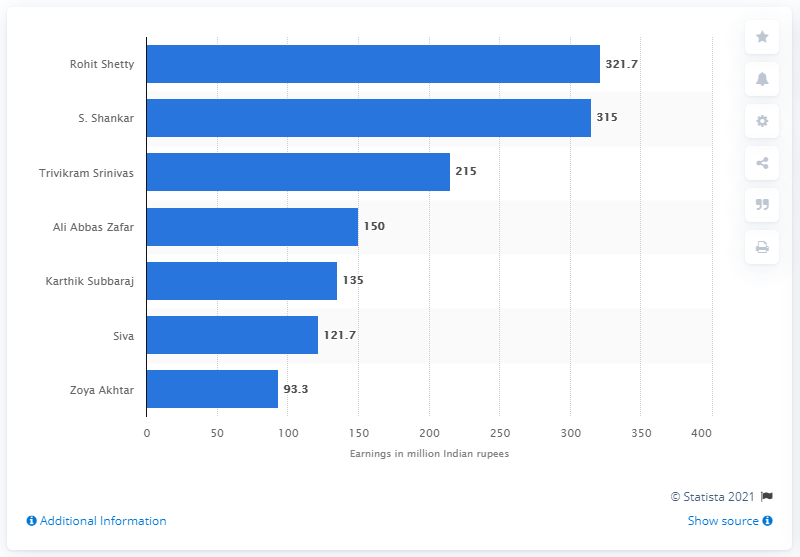Identify some key points in this picture. According to a 2019 report, S. Shankar, a Tamil film director, was the leading director followed by Rohit Shetty in India. In 2019, Rohit Shetty was the leading director in India. 